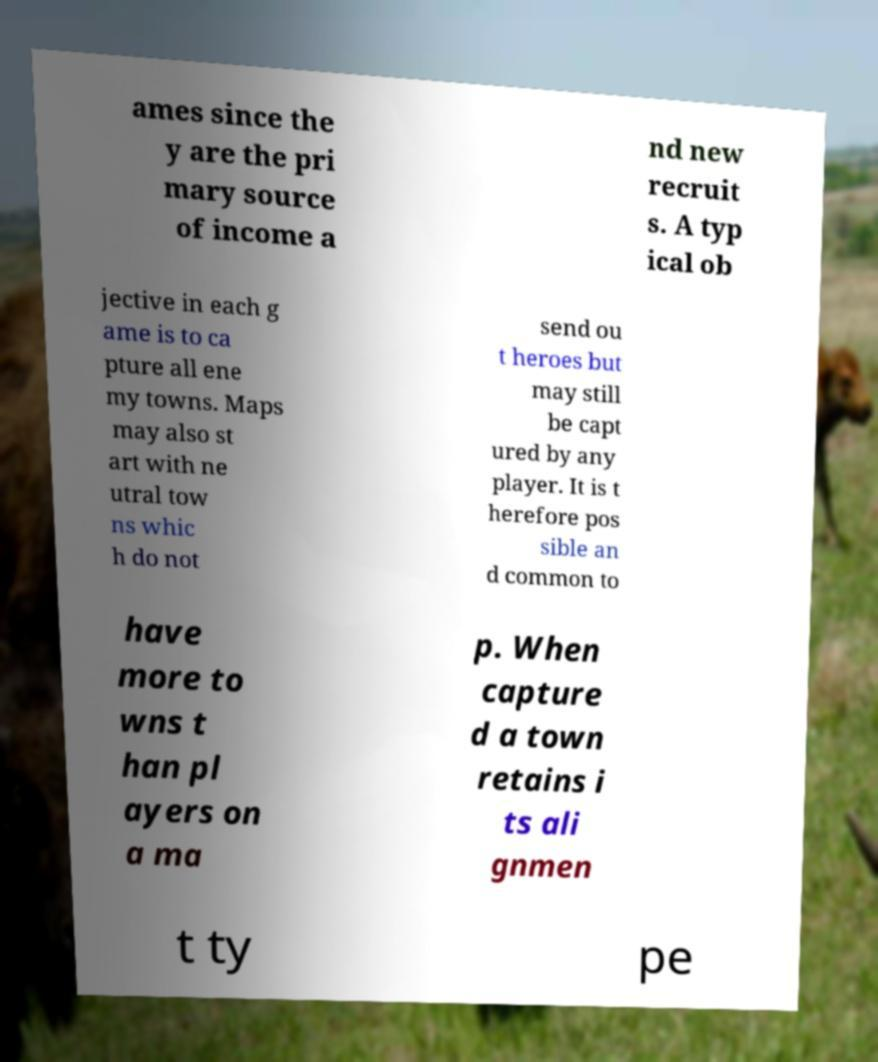Please identify and transcribe the text found in this image. ames since the y are the pri mary source of income a nd new recruit s. A typ ical ob jective in each g ame is to ca pture all ene my towns. Maps may also st art with ne utral tow ns whic h do not send ou t heroes but may still be capt ured by any player. It is t herefore pos sible an d common to have more to wns t han pl ayers on a ma p. When capture d a town retains i ts ali gnmen t ty pe 